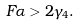<formula> <loc_0><loc_0><loc_500><loc_500>F \alpha > 2 \gamma _ { 4 } .</formula> 